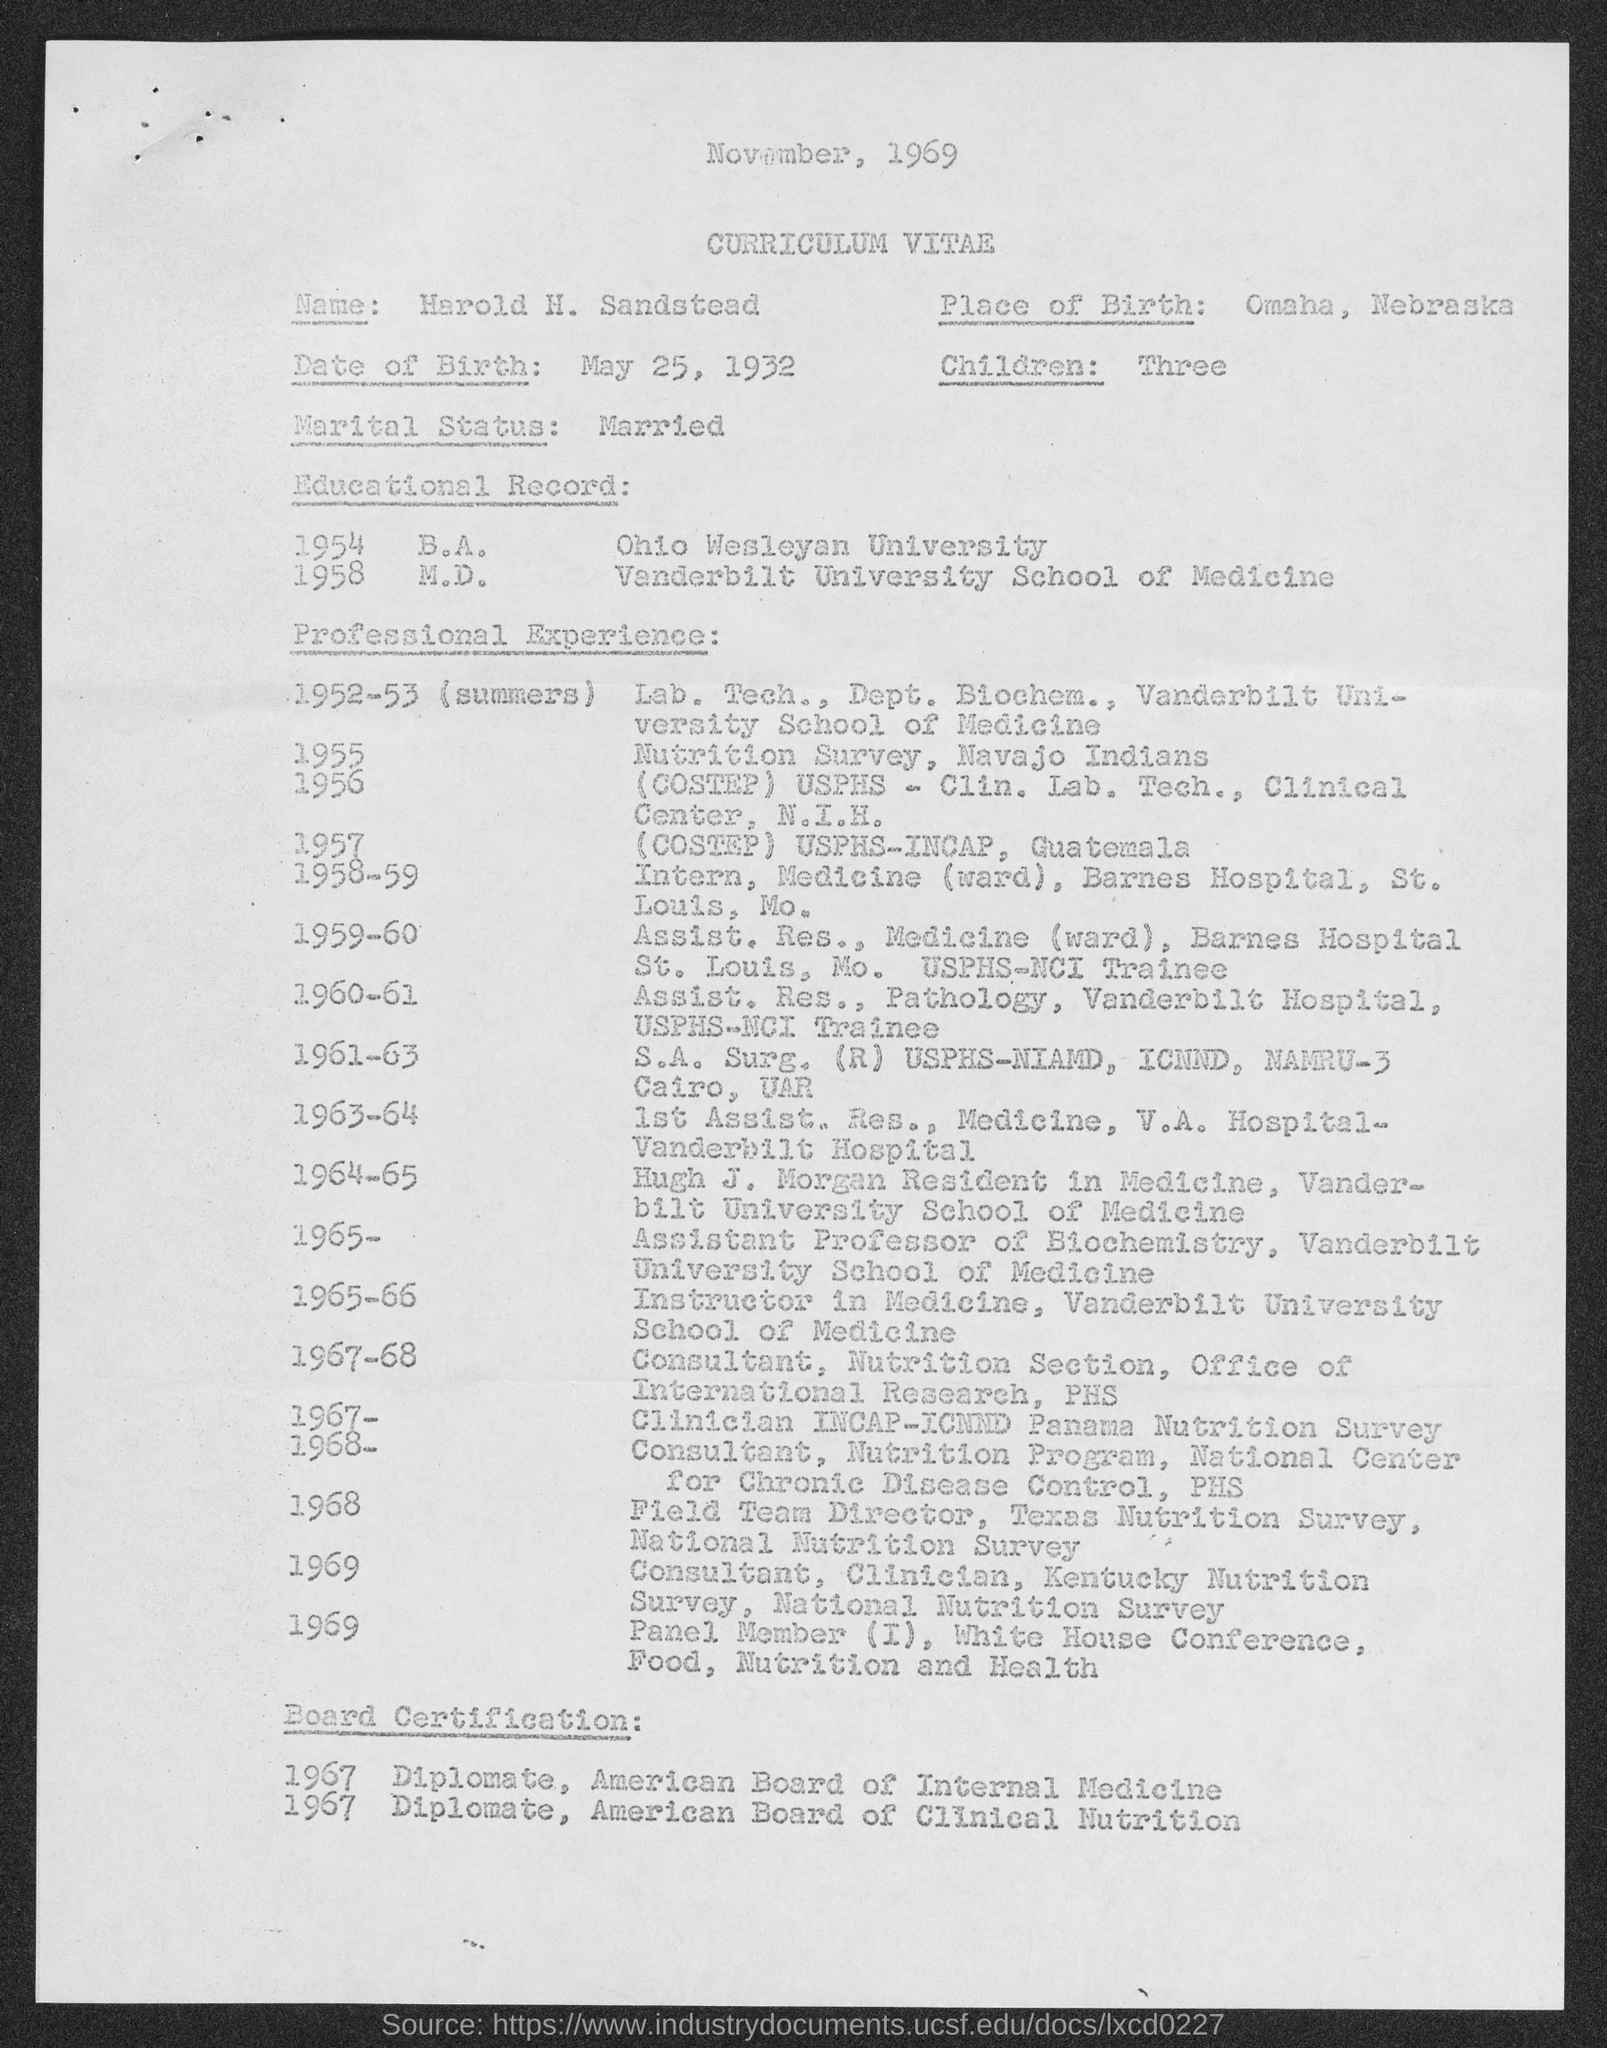Identify some key points in this picture. The date mentioned at the top of the page is November, 1969. The given page mentions three children. The M.D. degree mentioned in the given page was completed by the individual at Vanderbilt University School of Medicine. The date of birth mentioned in the given page is May 25, 1932. The person who completed their B.A. degree at Ohio Wesleyan University is from the university. 